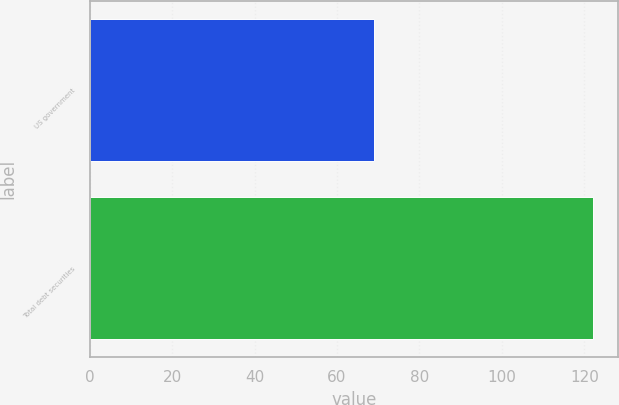<chart> <loc_0><loc_0><loc_500><loc_500><bar_chart><fcel>US government<fcel>Total debt securities<nl><fcel>69<fcel>122<nl></chart> 